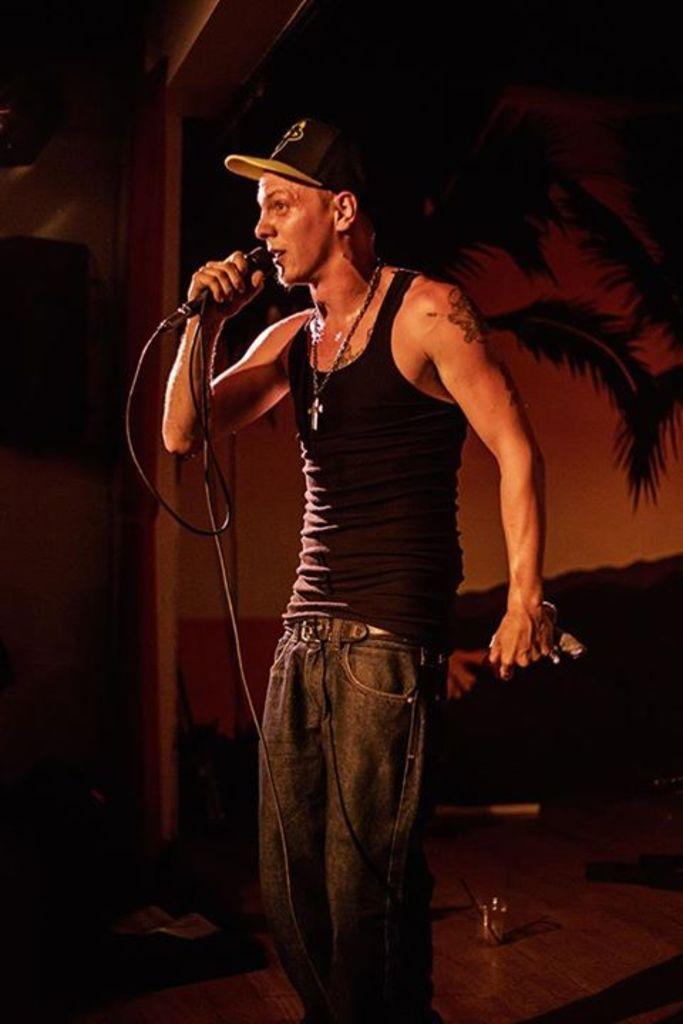In one or two sentences, can you explain what this image depicts? There is a man standing and holding a microphone and wire cap. We can see glass and objects on the surface. In the background we can see screen and object on a wall. 